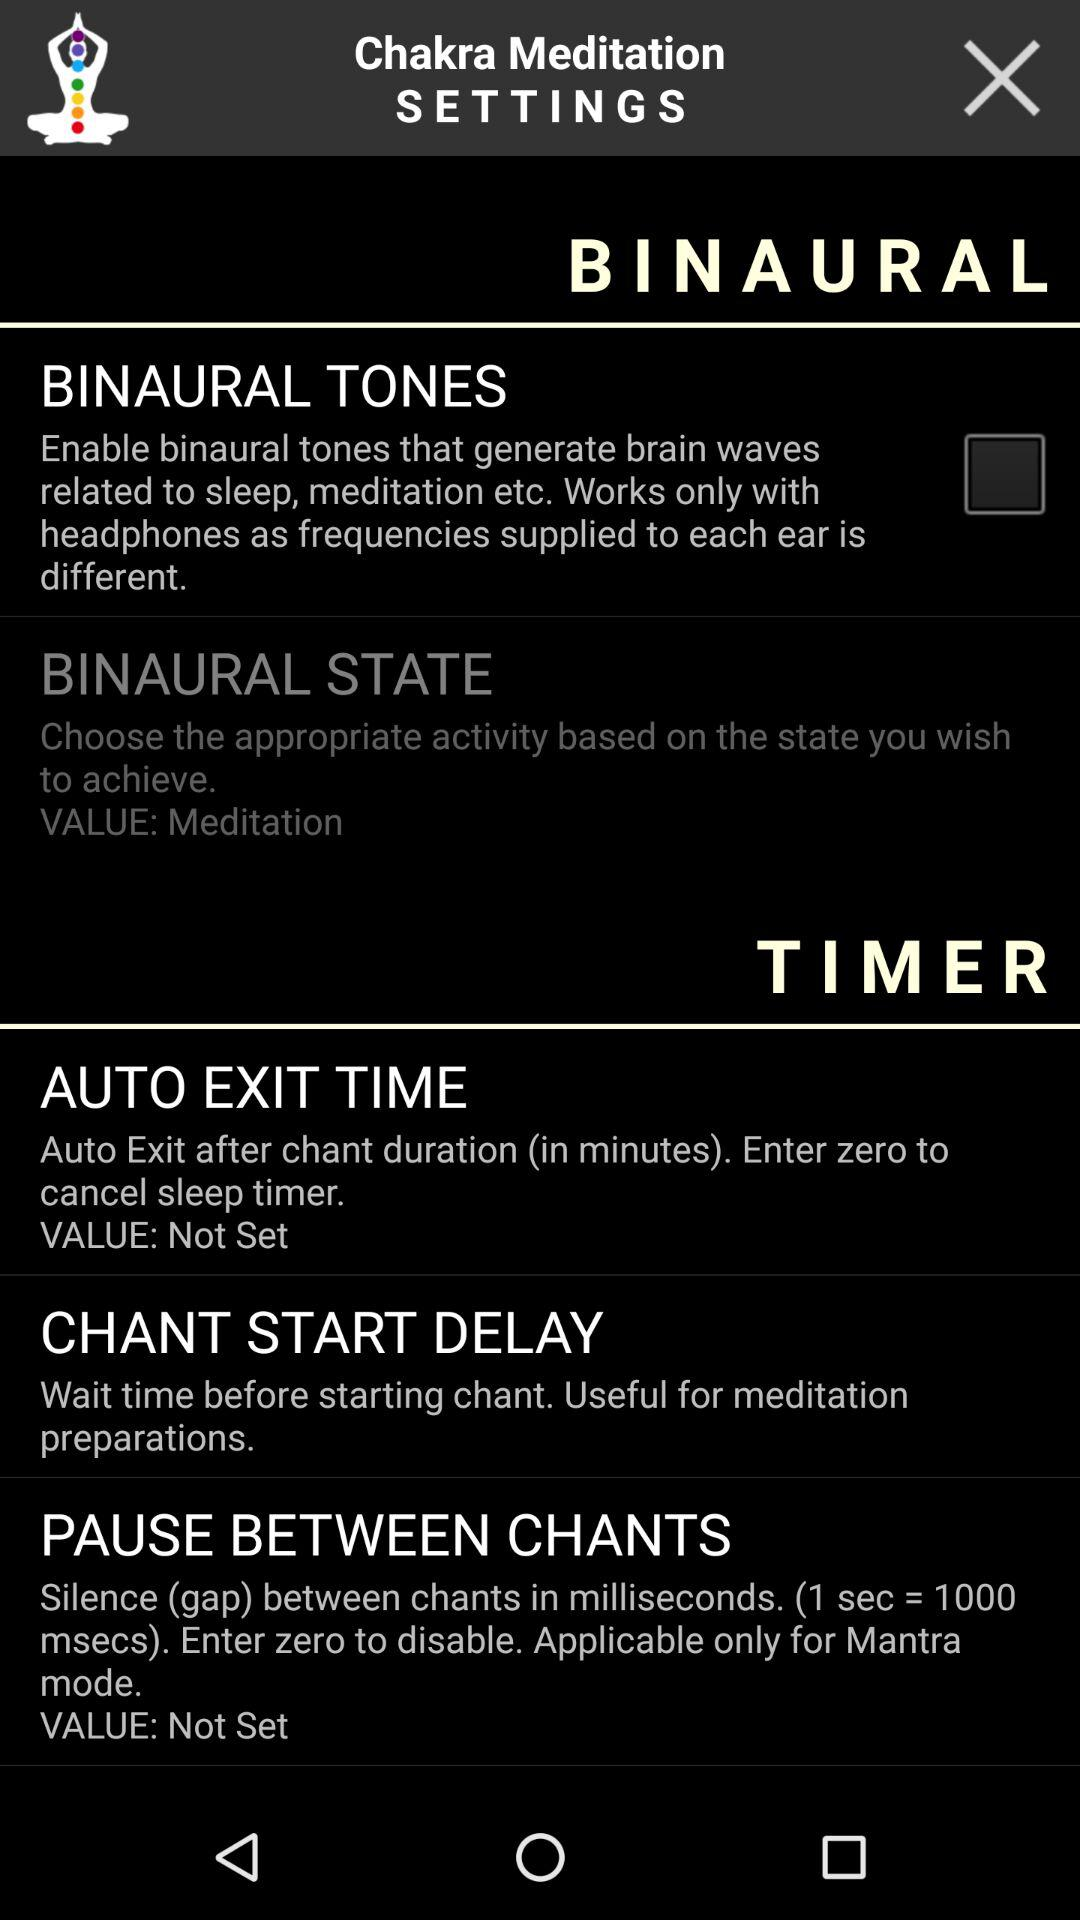Is the "Auto exit time" value set? The "Auto exit time" value is not set. 